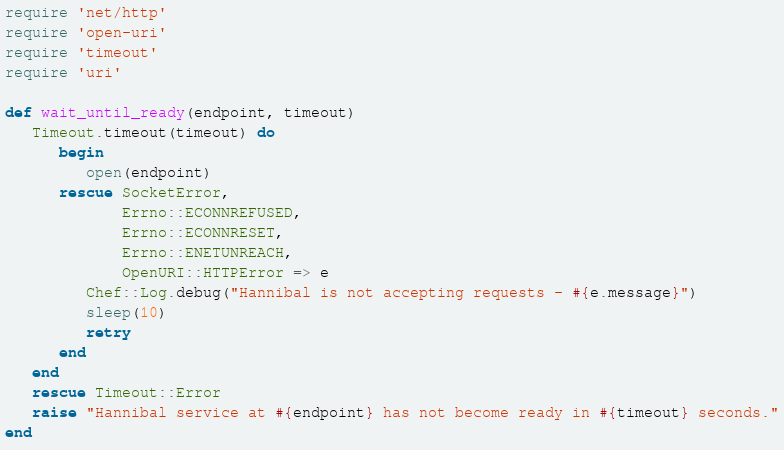Convert code to text. <code><loc_0><loc_0><loc_500><loc_500><_Ruby_>require 'net/http'
require 'open-uri'
require 'timeout'
require 'uri'

def wait_until_ready(endpoint, timeout)
   Timeout.timeout(timeout) do
      begin
         open(endpoint)
      rescue SocketError,
             Errno::ECONNREFUSED,
             Errno::ECONNRESET,
             Errno::ENETUNREACH,
             OpenURI::HTTPError => e
         Chef::Log.debug("Hannibal is not accepting requests - #{e.message}")
         sleep(10)
         retry
      end
   end
   rescue Timeout::Error
   raise "Hannibal service at #{endpoint} has not become ready in #{timeout} seconds."
end

</code> 